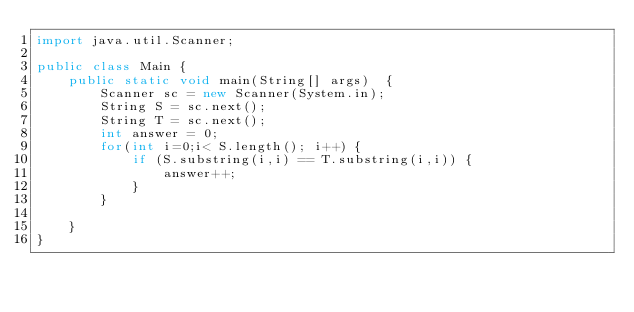Convert code to text. <code><loc_0><loc_0><loc_500><loc_500><_Java_>import java.util.Scanner;

public class Main {
    public static void main(String[] args)  {
        Scanner sc = new Scanner(System.in);
        String S = sc.next();
        String T = sc.next();
        int answer = 0;
        for(int i=0;i< S.length(); i++) {
            if (S.substring(i,i) == T.substring(i,i)) {
                answer++;
            }
        }

    }
}
</code> 